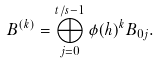Convert formula to latex. <formula><loc_0><loc_0><loc_500><loc_500>B ^ { ( k ) } = \bigoplus _ { j = 0 } ^ { t / s - 1 } \phi ( h ) ^ { k } B _ { 0 j } .</formula> 